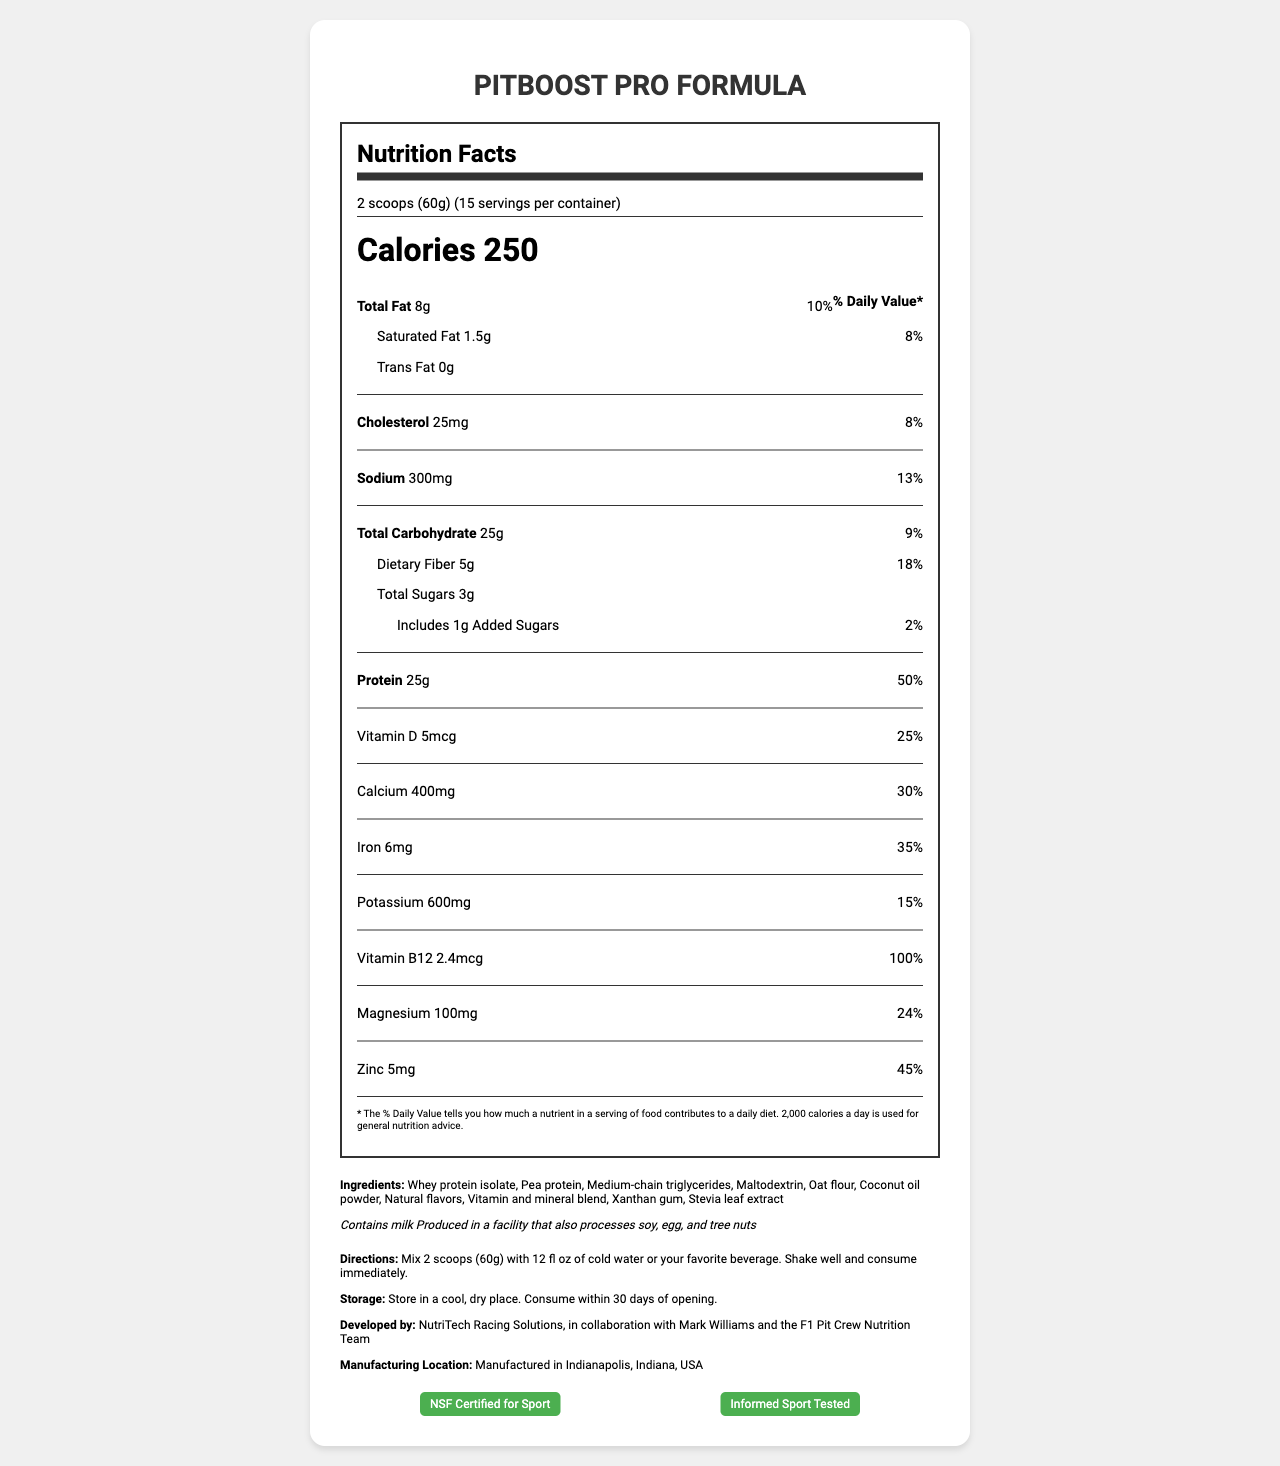what is the serving size? The serving size is explicitly stated at the top of the nutrition facts section.
Answer: 2 scoops (60g) how many servings are in each container? This information is provided in the same section as the serving size.
Answer: 15 how many calories are in one serving? The calorie count is highlighted in a larger font in the nutrition facts section.
Answer: 250 what is the percentage of daily value for saturated fat? The daily value percentage for saturated fat can be found under the total fat information.
Answer: 8% how much protein is in one serving? The protein amount is listed along with its daily value percentage.
Answer: 25g which of the following vitamins has the highest daily value percentage? A. Vitamin D B. Calcium C. Vitamin B12 D. Zinc Vitamin B12 has a daily value of 100%, which is the highest percentage among the listed vitamins.
Answer: C. Vitamin B12 how much sodium is in a serving? A. 200mg B. 300mg C. 400mg D. 500mg The sodium content is clearly stated as 300mg along with its daily value percentage.
Answer: B. 300mg does this product contain any added sugars? The document mentions that it includes 1g of added sugars.
Answer: Yes is this product NSF Certified for Sport? The certification section lists NSF Certified for Sport.
Answer: Yes please summarize the main idea of the document. The document comprehensively covers all aspects of the meal replacement shake, from nutritional content to certifications, ensuring consumers are fully informed.
Answer: The document provides a detailed Nutrition Facts Label for "PitBoost Pro Formula," a meal replacement shake designed for pit crew members. It highlights serving size, calories, macronutrient content, vitamins, minerals, ingredients, allergens, directions, storage instructions, development team, manufacturing location, and certifications. who developed this product? This information is found under the additional info section of the document.
Answer: NutriTech Racing Solutions, in collaboration with Mark Williams and the F1 Pit Crew Nutrition Team where is this product manufactured? The manufacturing location is given at the bottom of the document.
Answer: Indianapolis, Indiana, USA is there coconut oil in the ingredient list? Coconut oil powder is listed as one of the ingredients.
Answer: Yes what is the daily value percentage for Vitamin D? The daily value percentage for Vitamin D is listed under the vitamins section.
Answer: 25% how many grams of dietary fiber are in a serving? The dietary fiber content and its daily value percentage are listed under the total carbohydrate section.
Answer: 5g what kind of allergens are present in this product? This information is clearly mentioned in the allergens section.
Answer: Contains milk. Produced in a facility that also processes soy, egg, and tree nuts. does the product contain any trans fat? The document states there is 0g of trans fat in the product.
Answer: No how soon should the product be consumed after opening? The storage instructions specify that the product should be consumed within 30 days of opening.
Answer: Within 30 days what are the directions for consuming this product? Directions for consumption are provided under the additional info section.
Answer: Mix 2 scoops (60g) with 12 fl oz of cold water or your favorite beverage. Shake well and consume immediately. what is the net weight of the product? The document does not provide information about the net weight of the entire product container.
Answer: Cannot be determined 